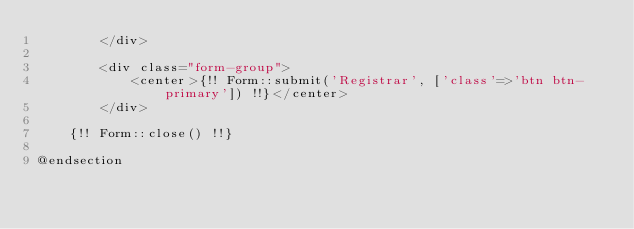<code> <loc_0><loc_0><loc_500><loc_500><_PHP_>		</div>

		<div class="form-group">
			<center>{!! Form::submit('Registrar', ['class'=>'btn btn-primary']) !!}</center>
		</div>

	{!! Form::close() !!}

@endsection</code> 